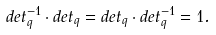Convert formula to latex. <formula><loc_0><loc_0><loc_500><loc_500>d e t _ { q } ^ { - 1 } \cdot d e t _ { q } = d e t _ { q } \cdot d e t _ { q } ^ { - 1 } = 1 .</formula> 